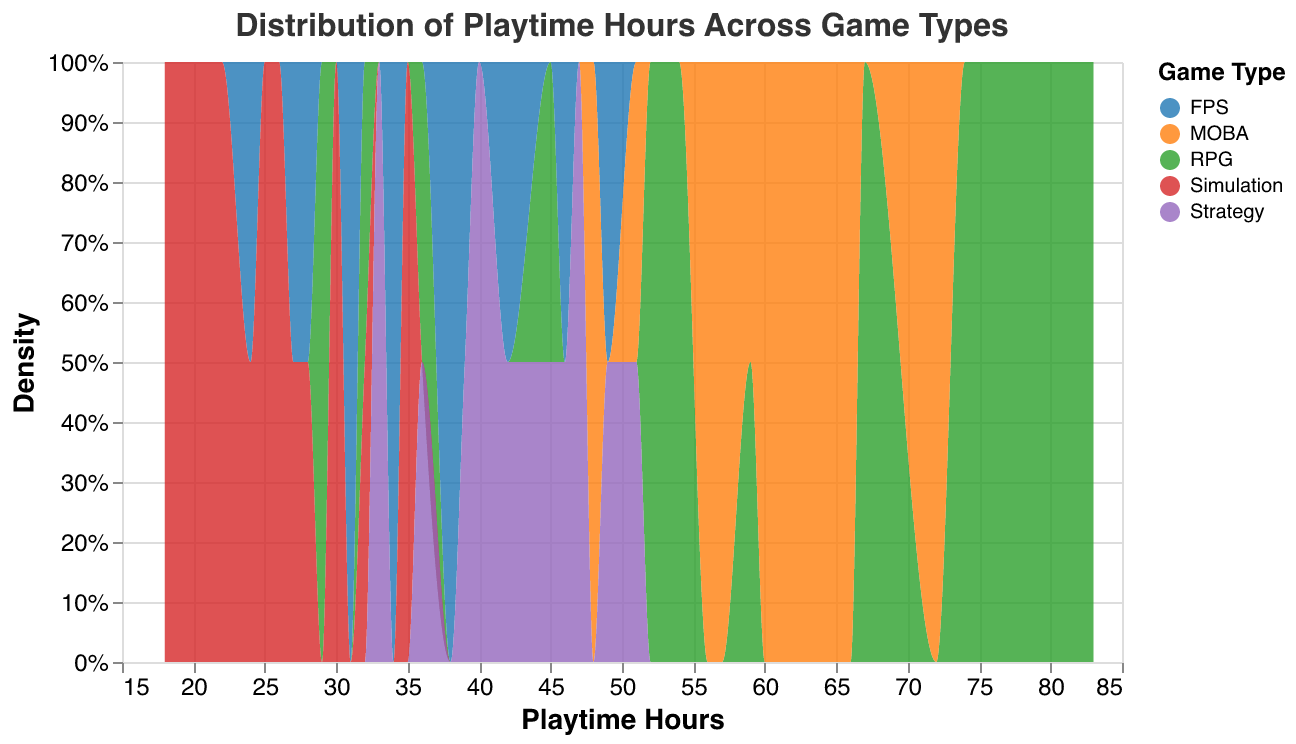What is the title of the figure? The title is typically displayed at the top of the figure and summarizes what the plot is about. Here, it specifies the data being shown: "Distribution of Playtime Hours Across Game Types".
Answer: Distribution of Playtime Hours Across Game Types What color scheme is used to differentiate between the game types? The color scheme for categorical data is shown in the legend on the plot, which uses the "category10" scheme.
Answer: category10 Which game type has the highest density around 40 playtime hours? By viewing the plot around the 40 playtime hours mark and identifying the peak of the density plot, we can see which game type is most prominent there.
Answer: FPS What is the distribution shape for MOBA games in terms of playtime hours? By examining the area under the curve for MOBA in the density plot, we observe that it has a relatively uniform distribution between 48 and 72 playtime hours.
Answer: Uniform between 48 and 72 hours Among RPG and Simulation, which has a wider range of playtime hours? The range is determined by the spread of the density plot along the x-axis. RPG playtime hours span from 29 to 83, while Simulation spans from 18 to 35.
Answer: RPG What is the typical playtime range for Strategy games according to this plot? By analyzing the range of the density plot for Strategy games, we notice the bulk of density is centered between 33 and 51 playtime hours.
Answer: 33 to 51 hours How many game types are represented in the plot? The number of unique colors and labels in the legend of the density plot indicates the number of game types.
Answer: 5 Which game type shows the highest peak density overall? The density peak is identified by the highest point in the density plot. The RPG game type shows the highest peak.
Answer: RPG Do MOBA games have a higher or lower playtime density compared to FPS games around the 60 hours mark? By comparing the plot areas around the 60 hours mark for both game types, it is clear that MOBA has a higher density at that point.
Answer: Higher Which game type appears to have the most consistent playtime among players? The consistency is shown by the narrowness and peak of the density plot. Simulation games show the narrowest and most peaked plot, indicating more consistent playtimes.
Answer: Simulation 